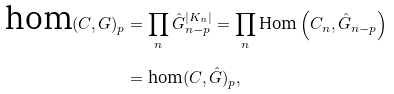Convert formula to latex. <formula><loc_0><loc_0><loc_500><loc_500>\text {hom} ( C , G ) _ { p } & = \prod _ { n } \hat { G } _ { n - p } ^ { | K _ { n } | } = \prod _ { n } \text {Hom} \left ( C _ { n } , \hat { G } _ { n - p } \right ) \\ & = \text {hom} ( C , \hat { G } ) _ { p } ,</formula> 